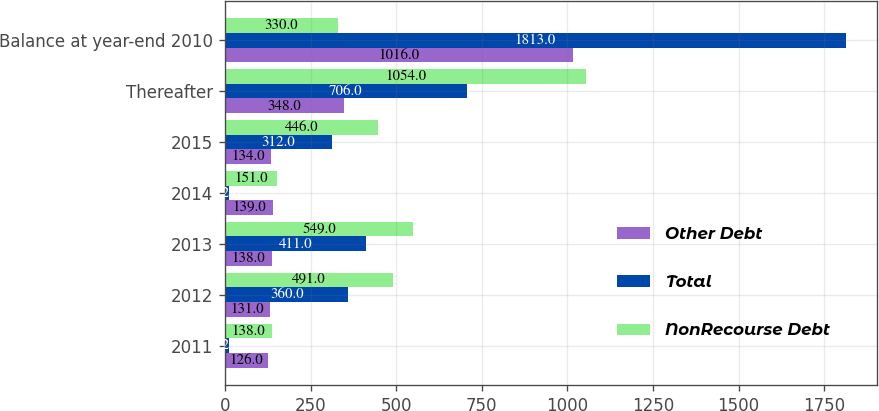Convert chart to OTSL. <chart><loc_0><loc_0><loc_500><loc_500><stacked_bar_chart><ecel><fcel>2011<fcel>2012<fcel>2013<fcel>2014<fcel>2015<fcel>Thereafter<fcel>Balance at year-end 2010<nl><fcel>Other Debt<fcel>126<fcel>131<fcel>138<fcel>139<fcel>134<fcel>348<fcel>1016<nl><fcel>Total<fcel>12<fcel>360<fcel>411<fcel>12<fcel>312<fcel>706<fcel>1813<nl><fcel>NonRecourse Debt<fcel>138<fcel>491<fcel>549<fcel>151<fcel>446<fcel>1054<fcel>330<nl></chart> 